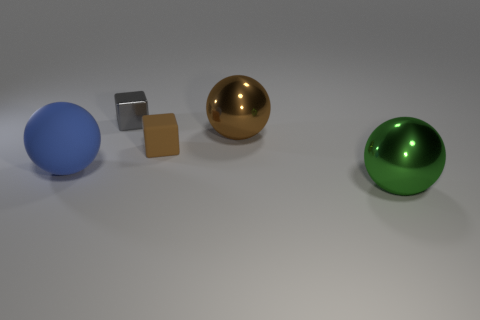There is another metal thing that is the same size as the brown metal thing; what is its shape?
Offer a very short reply. Sphere. Are there an equal number of matte blocks to the left of the large blue ball and brown objects that are behind the shiny block?
Offer a terse response. Yes. Do the large sphere that is right of the brown sphere and the small gray block have the same material?
Give a very brief answer. Yes. There is a block that is the same size as the gray object; what is its material?
Provide a succinct answer. Rubber. How many other objects are the same material as the green ball?
Keep it short and to the point. 2. There is a blue rubber thing; is its size the same as the brown sphere right of the small gray metal object?
Make the answer very short. Yes. Are there fewer cubes that are behind the green ball than things that are in front of the brown metal sphere?
Offer a very short reply. Yes. How big is the rubber object that is to the right of the large rubber thing?
Provide a short and direct response. Small. Does the blue matte ball have the same size as the gray metallic block?
Make the answer very short. No. How many objects are to the left of the brown shiny ball and in front of the tiny gray metal object?
Keep it short and to the point. 2. 